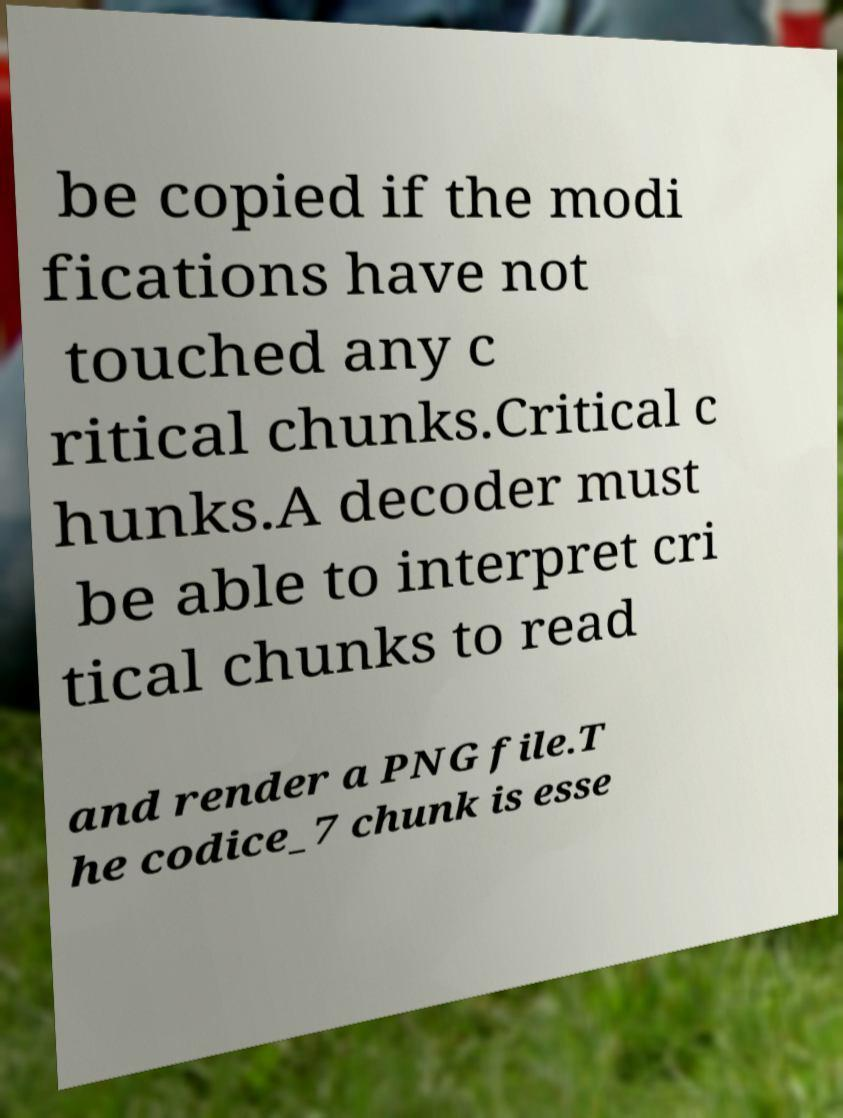Please identify and transcribe the text found in this image. be copied if the modi fications have not touched any c ritical chunks.Critical c hunks.A decoder must be able to interpret cri tical chunks to read and render a PNG file.T he codice_7 chunk is esse 